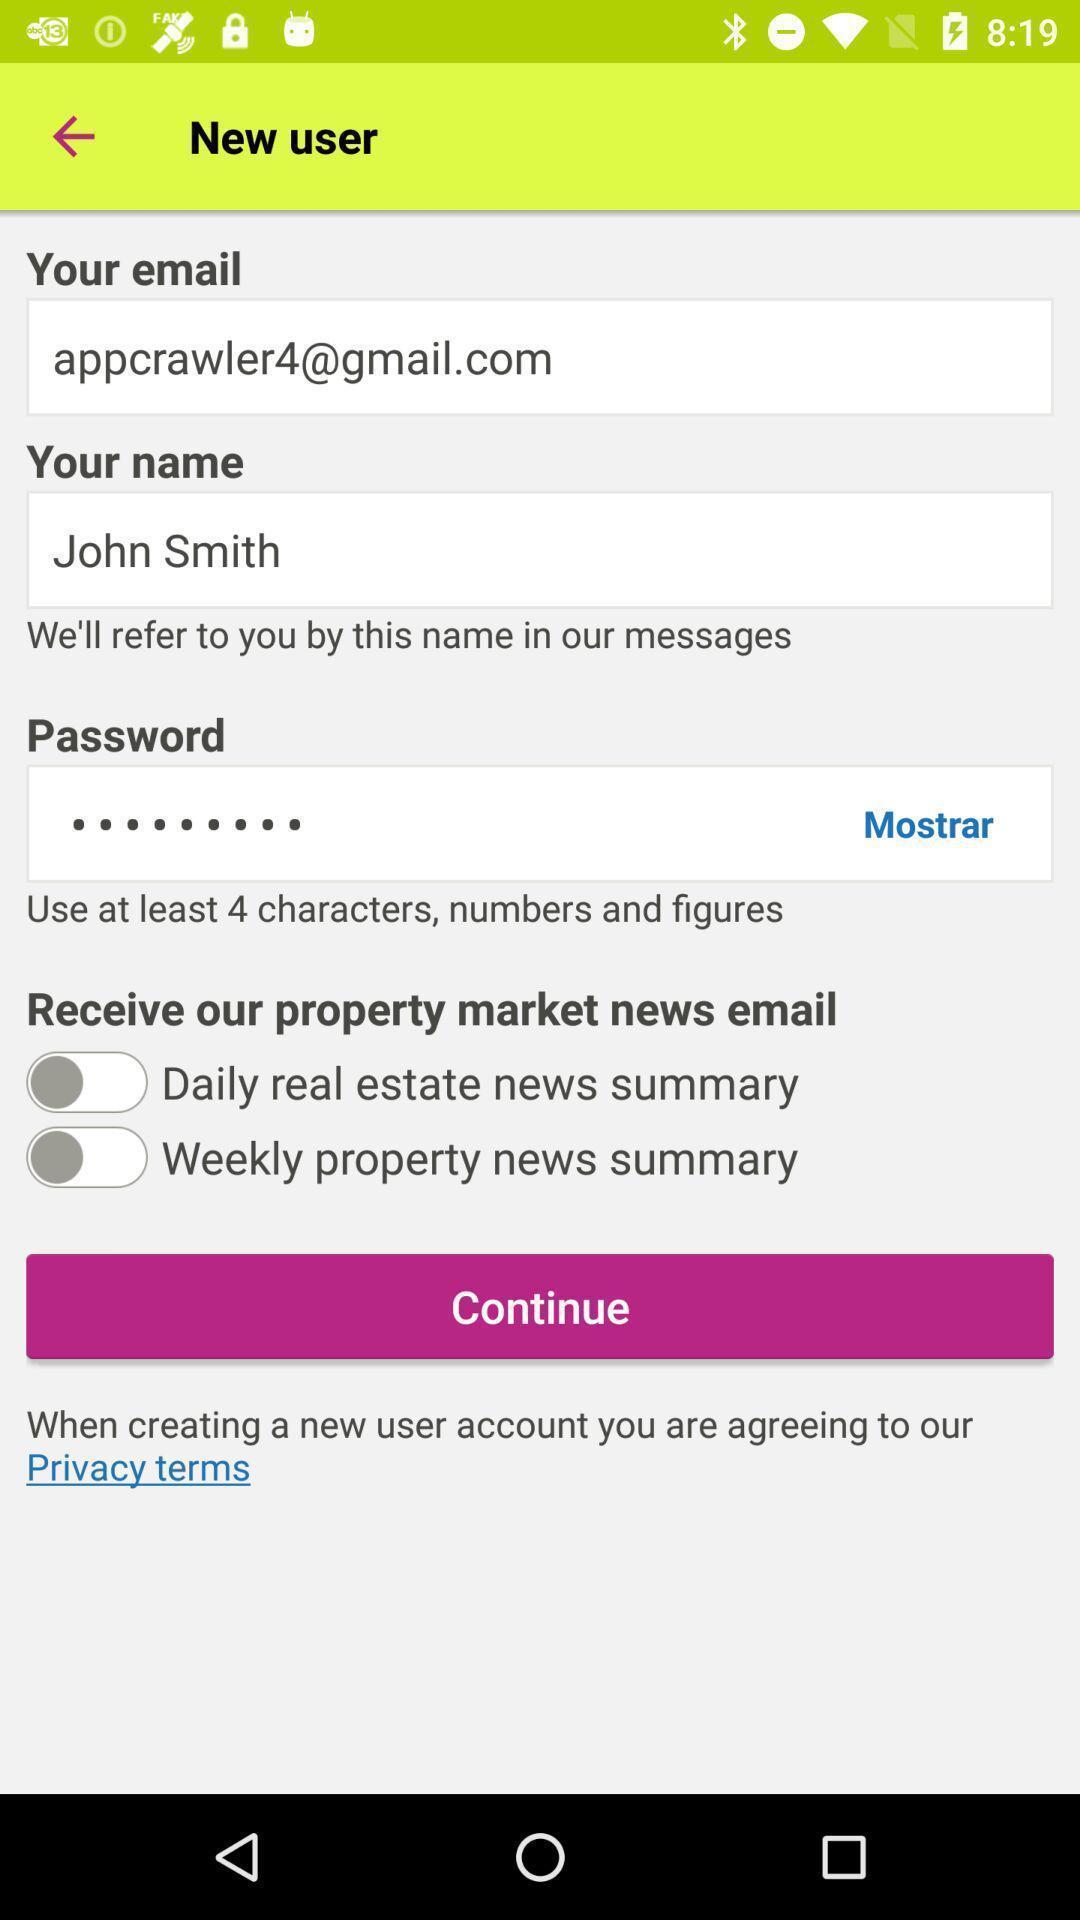Describe the visual elements of this screenshot. Page requesting to continue on a property marketing app. 